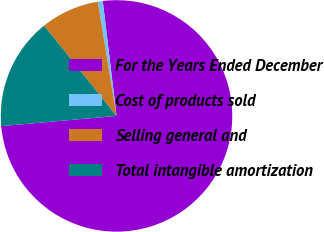Convert chart to OTSL. <chart><loc_0><loc_0><loc_500><loc_500><pie_chart><fcel>For the Years Ended December<fcel>Cost of products sold<fcel>Selling general and<fcel>Total intangible amortization<nl><fcel>75.5%<fcel>0.69%<fcel>8.17%<fcel>15.65%<nl></chart> 